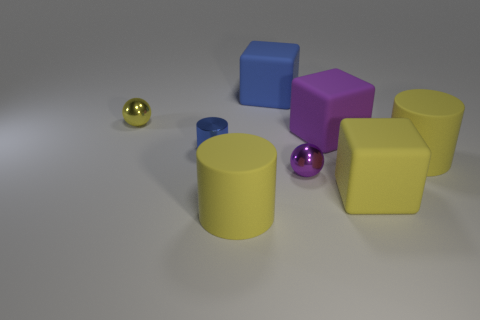There is a large cube that is behind the yellow metal sphere; how many big blocks are to the right of it?
Make the answer very short. 2. There is a metal thing that is right of the metallic cylinder; is it the same shape as the yellow thing left of the blue cylinder?
Make the answer very short. Yes. How many small metal things are behind the large purple block and to the right of the tiny yellow shiny ball?
Provide a succinct answer. 0. Are there any big metallic cylinders that have the same color as the tiny metal cylinder?
Provide a short and direct response. No. There is a blue object that is the same size as the purple block; what shape is it?
Ensure brevity in your answer.  Cube. There is a small blue metallic thing; are there any blue metallic cylinders right of it?
Your answer should be compact. No. Is the yellow cylinder that is right of the purple sphere made of the same material as the cube that is in front of the purple sphere?
Offer a very short reply. Yes. How many purple matte things are the same size as the blue matte object?
Provide a succinct answer. 1. What is the shape of the big matte object that is the same color as the tiny cylinder?
Your answer should be compact. Cube. There is a blue object behind the tiny yellow metal thing; what is its material?
Provide a succinct answer. Rubber. 